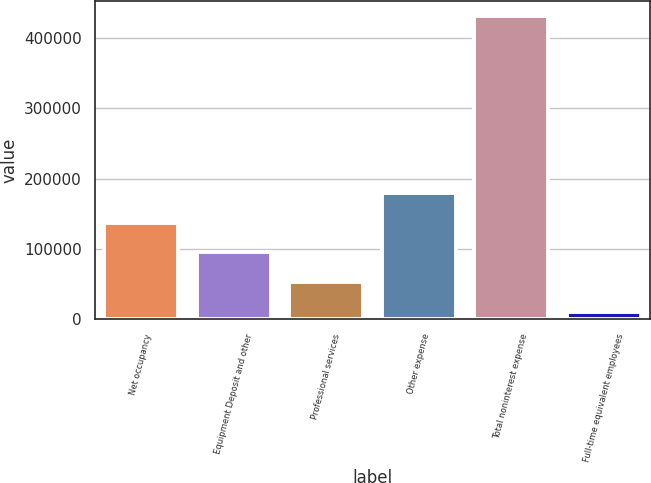<chart> <loc_0><loc_0><loc_500><loc_500><bar_chart><fcel>Net occupancy<fcel>Equipment Deposit and other<fcel>Professional services<fcel>Other expense<fcel>Total noninterest expense<fcel>Full-time equivalent employees<nl><fcel>136954<fcel>95050.8<fcel>53147.9<fcel>178857<fcel>430274<fcel>11245<nl></chart> 